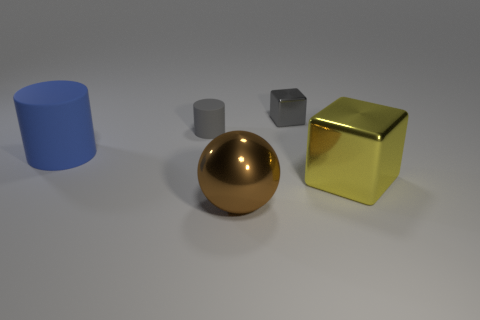Is there any other thing that is the same size as the blue cylinder?
Your response must be concise. Yes. How many other things are there of the same shape as the large yellow thing?
Offer a very short reply. 1. Does the large thing that is behind the large yellow cube have the same material as the tiny object that is to the right of the tiny matte object?
Your answer should be compact. No. What shape is the shiny object that is behind the metal sphere and in front of the gray metallic object?
Give a very brief answer. Cube. Are there any other things that are made of the same material as the big cylinder?
Give a very brief answer. Yes. There is a large object that is both on the left side of the tiny block and right of the gray rubber object; what is it made of?
Your response must be concise. Metal. What is the shape of the big brown object that is made of the same material as the tiny block?
Your answer should be very brief. Sphere. Are there any other things of the same color as the shiny sphere?
Ensure brevity in your answer.  No. Are there more blocks that are in front of the gray cylinder than big blue cylinders?
Offer a very short reply. No. What is the material of the small cylinder?
Your response must be concise. Rubber. 